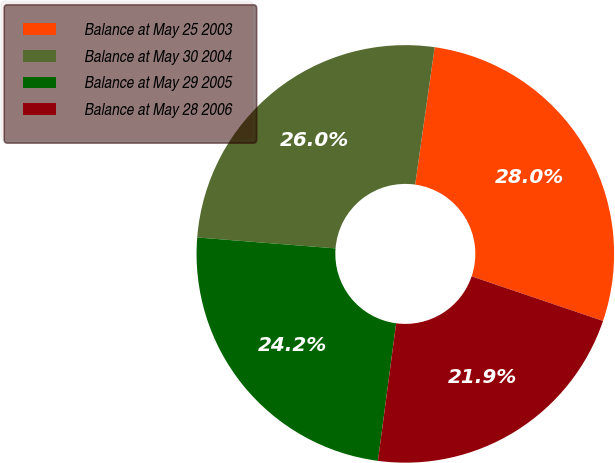Convert chart to OTSL. <chart><loc_0><loc_0><loc_500><loc_500><pie_chart><fcel>Balance at May 25 2003<fcel>Balance at May 30 2004<fcel>Balance at May 29 2005<fcel>Balance at May 28 2006<nl><fcel>27.96%<fcel>25.99%<fcel>24.16%<fcel>21.89%<nl></chart> 